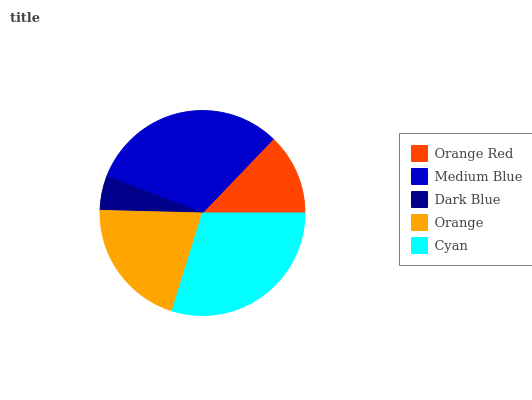Is Dark Blue the minimum?
Answer yes or no. Yes. Is Medium Blue the maximum?
Answer yes or no. Yes. Is Medium Blue the minimum?
Answer yes or no. No. Is Dark Blue the maximum?
Answer yes or no. No. Is Medium Blue greater than Dark Blue?
Answer yes or no. Yes. Is Dark Blue less than Medium Blue?
Answer yes or no. Yes. Is Dark Blue greater than Medium Blue?
Answer yes or no. No. Is Medium Blue less than Dark Blue?
Answer yes or no. No. Is Orange the high median?
Answer yes or no. Yes. Is Orange the low median?
Answer yes or no. Yes. Is Medium Blue the high median?
Answer yes or no. No. Is Medium Blue the low median?
Answer yes or no. No. 